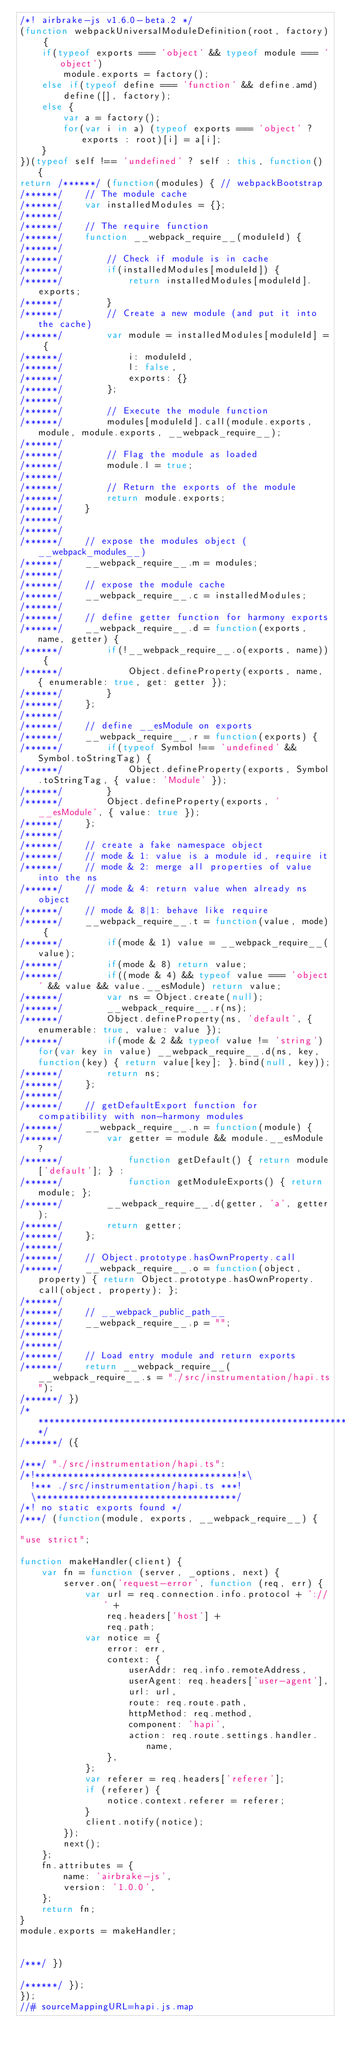Convert code to text. <code><loc_0><loc_0><loc_500><loc_500><_JavaScript_>/*! airbrake-js v1.6.0-beta.2 */
(function webpackUniversalModuleDefinition(root, factory) {
	if(typeof exports === 'object' && typeof module === 'object')
		module.exports = factory();
	else if(typeof define === 'function' && define.amd)
		define([], factory);
	else {
		var a = factory();
		for(var i in a) (typeof exports === 'object' ? exports : root)[i] = a[i];
	}
})(typeof self !== 'undefined' ? self : this, function() {
return /******/ (function(modules) { // webpackBootstrap
/******/ 	// The module cache
/******/ 	var installedModules = {};
/******/
/******/ 	// The require function
/******/ 	function __webpack_require__(moduleId) {
/******/
/******/ 		// Check if module is in cache
/******/ 		if(installedModules[moduleId]) {
/******/ 			return installedModules[moduleId].exports;
/******/ 		}
/******/ 		// Create a new module (and put it into the cache)
/******/ 		var module = installedModules[moduleId] = {
/******/ 			i: moduleId,
/******/ 			l: false,
/******/ 			exports: {}
/******/ 		};
/******/
/******/ 		// Execute the module function
/******/ 		modules[moduleId].call(module.exports, module, module.exports, __webpack_require__);
/******/
/******/ 		// Flag the module as loaded
/******/ 		module.l = true;
/******/
/******/ 		// Return the exports of the module
/******/ 		return module.exports;
/******/ 	}
/******/
/******/
/******/ 	// expose the modules object (__webpack_modules__)
/******/ 	__webpack_require__.m = modules;
/******/
/******/ 	// expose the module cache
/******/ 	__webpack_require__.c = installedModules;
/******/
/******/ 	// define getter function for harmony exports
/******/ 	__webpack_require__.d = function(exports, name, getter) {
/******/ 		if(!__webpack_require__.o(exports, name)) {
/******/ 			Object.defineProperty(exports, name, { enumerable: true, get: getter });
/******/ 		}
/******/ 	};
/******/
/******/ 	// define __esModule on exports
/******/ 	__webpack_require__.r = function(exports) {
/******/ 		if(typeof Symbol !== 'undefined' && Symbol.toStringTag) {
/******/ 			Object.defineProperty(exports, Symbol.toStringTag, { value: 'Module' });
/******/ 		}
/******/ 		Object.defineProperty(exports, '__esModule', { value: true });
/******/ 	};
/******/
/******/ 	// create a fake namespace object
/******/ 	// mode & 1: value is a module id, require it
/******/ 	// mode & 2: merge all properties of value into the ns
/******/ 	// mode & 4: return value when already ns object
/******/ 	// mode & 8|1: behave like require
/******/ 	__webpack_require__.t = function(value, mode) {
/******/ 		if(mode & 1) value = __webpack_require__(value);
/******/ 		if(mode & 8) return value;
/******/ 		if((mode & 4) && typeof value === 'object' && value && value.__esModule) return value;
/******/ 		var ns = Object.create(null);
/******/ 		__webpack_require__.r(ns);
/******/ 		Object.defineProperty(ns, 'default', { enumerable: true, value: value });
/******/ 		if(mode & 2 && typeof value != 'string') for(var key in value) __webpack_require__.d(ns, key, function(key) { return value[key]; }.bind(null, key));
/******/ 		return ns;
/******/ 	};
/******/
/******/ 	// getDefaultExport function for compatibility with non-harmony modules
/******/ 	__webpack_require__.n = function(module) {
/******/ 		var getter = module && module.__esModule ?
/******/ 			function getDefault() { return module['default']; } :
/******/ 			function getModuleExports() { return module; };
/******/ 		__webpack_require__.d(getter, 'a', getter);
/******/ 		return getter;
/******/ 	};
/******/
/******/ 	// Object.prototype.hasOwnProperty.call
/******/ 	__webpack_require__.o = function(object, property) { return Object.prototype.hasOwnProperty.call(object, property); };
/******/
/******/ 	// __webpack_public_path__
/******/ 	__webpack_require__.p = "";
/******/
/******/
/******/ 	// Load entry module and return exports
/******/ 	return __webpack_require__(__webpack_require__.s = "./src/instrumentation/hapi.ts");
/******/ })
/************************************************************************/
/******/ ({

/***/ "./src/instrumentation/hapi.ts":
/*!*************************************!*\
  !*** ./src/instrumentation/hapi.ts ***!
  \*************************************/
/*! no static exports found */
/***/ (function(module, exports, __webpack_require__) {

"use strict";

function makeHandler(client) {
    var fn = function (server, _options, next) {
        server.on('request-error', function (req, err) {
            var url = req.connection.info.protocol + '://' +
                req.headers['host'] +
                req.path;
            var notice = {
                error: err,
                context: {
                    userAddr: req.info.remoteAddress,
                    userAgent: req.headers['user-agent'],
                    url: url,
                    route: req.route.path,
                    httpMethod: req.method,
                    component: 'hapi',
                    action: req.route.settings.handler.name,
                },
            };
            var referer = req.headers['referer'];
            if (referer) {
                notice.context.referer = referer;
            }
            client.notify(notice);
        });
        next();
    };
    fn.attributes = {
        name: 'airbrake-js',
        version: '1.0.0',
    };
    return fn;
}
module.exports = makeHandler;


/***/ })

/******/ });
});
//# sourceMappingURL=hapi.js.map</code> 